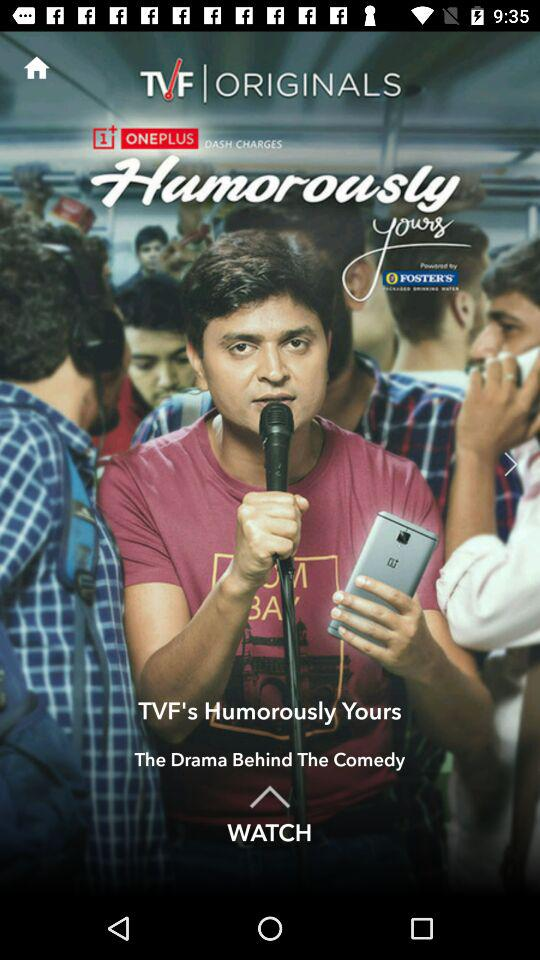What is the name of the application? The name of the application is "TVFPlay". 